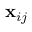Convert formula to latex. <formula><loc_0><loc_0><loc_500><loc_500>x _ { i j }</formula> 